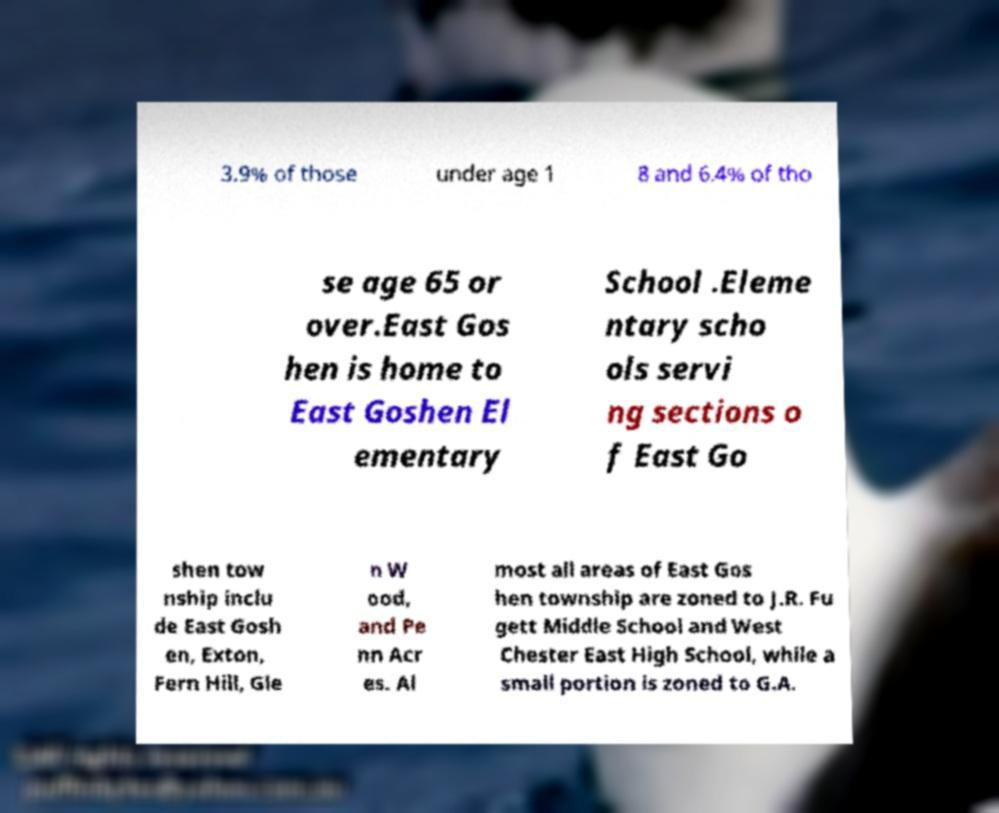Please read and relay the text visible in this image. What does it say? 3.9% of those under age 1 8 and 6.4% of tho se age 65 or over.East Gos hen is home to East Goshen El ementary School .Eleme ntary scho ols servi ng sections o f East Go shen tow nship inclu de East Gosh en, Exton, Fern Hill, Gle n W ood, and Pe nn Acr es. Al most all areas of East Gos hen township are zoned to J.R. Fu gett Middle School and West Chester East High School, while a small portion is zoned to G.A. 